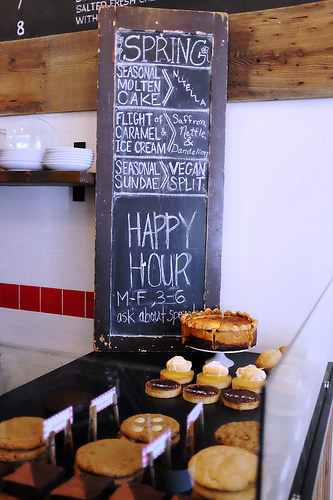<image>
Is there a pie in front of the chalkboard? Yes. The pie is positioned in front of the chalkboard, appearing closer to the camera viewpoint. 